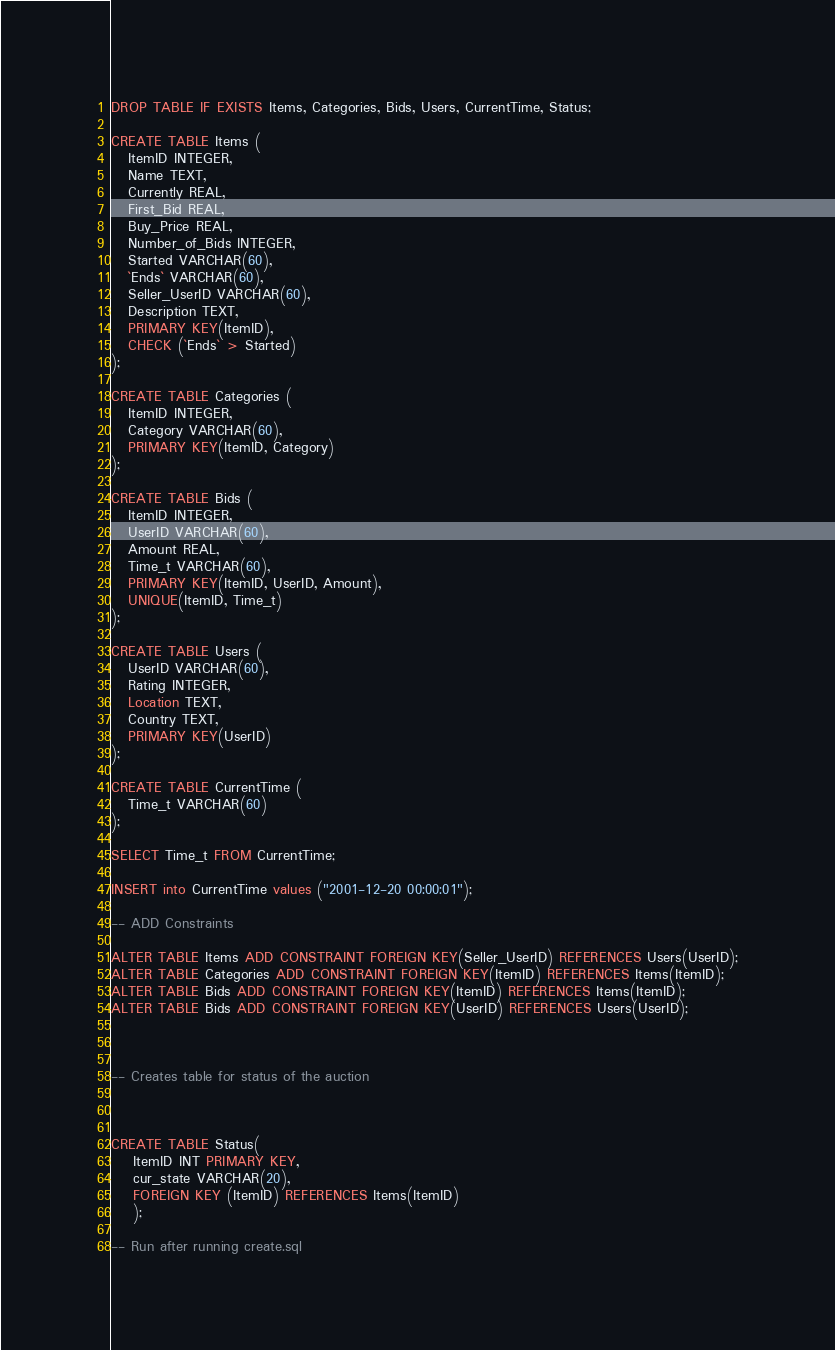Convert code to text. <code><loc_0><loc_0><loc_500><loc_500><_SQL_>DROP TABLE IF EXISTS Items, Categories, Bids, Users, CurrentTime, Status;

CREATE TABLE Items (
   ItemID INTEGER,
   Name TEXT,
   Currently REAL,
   First_Bid REAL,
   Buy_Price REAL,
   Number_of_Bids INTEGER,
   Started VARCHAR(60),
   `Ends` VARCHAR(60),
   Seller_UserID VARCHAR(60),
   Description TEXT,
   PRIMARY KEY(ItemID),
   CHECK (`Ends` > Started)
);

CREATE TABLE Categories (
   ItemID INTEGER,
   Category VARCHAR(60),
   PRIMARY KEY(ItemID, Category)
);

CREATE TABLE Bids (
   ItemID INTEGER,
   UserID VARCHAR(60),
   Amount REAL,
   Time_t VARCHAR(60),
   PRIMARY KEY(ItemID, UserID, Amount),
   UNIQUE(ItemID, Time_t)
);

CREATE TABLE Users (
   UserID VARCHAR(60),
   Rating INTEGER,
   Location TEXT,
   Country TEXT,
   PRIMARY KEY(UserID)
);

CREATE TABLE CurrentTime (
   Time_t VARCHAR(60)
);

SELECT Time_t FROM CurrentTime;

INSERT into CurrentTime values ("2001-12-20 00:00:01");

-- ADD Constraints

ALTER TABLE Items ADD CONSTRAINT FOREIGN KEY(Seller_UserID) REFERENCES Users(UserID);
ALTER TABLE Categories ADD CONSTRAINT FOREIGN KEY(ItemID) REFERENCES Items(ItemID);
ALTER TABLE Bids ADD CONSTRAINT FOREIGN KEY(ItemID) REFERENCES Items(ItemID);
ALTER TABLE Bids ADD CONSTRAINT FOREIGN KEY(UserID) REFERENCES Users(UserID);



-- Creates table for status of the auction



CREATE TABLE Status(
	ItemID INT PRIMARY KEY,
	cur_state VARCHAR(20),
	FOREIGN KEY (ItemID) REFERENCES Items(ItemID)
	);

-- Run after running create.sql
</code> 